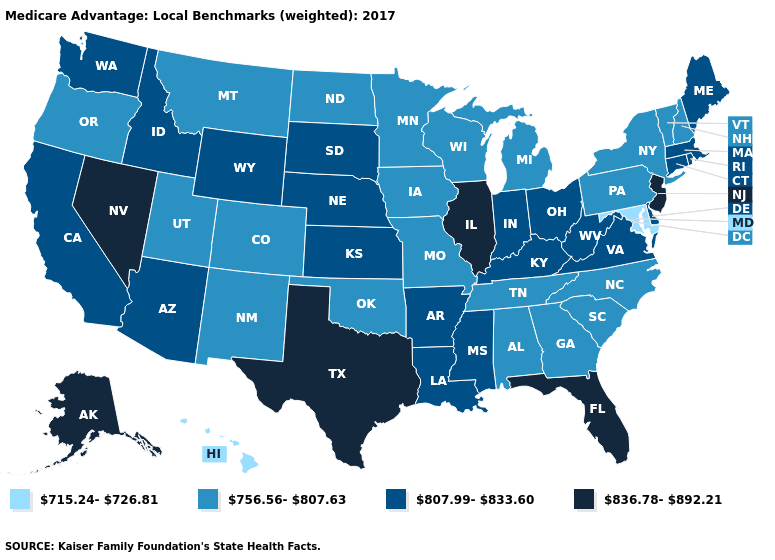What is the lowest value in the MidWest?
Be succinct. 756.56-807.63. Does Arkansas have the same value as Connecticut?
Keep it brief. Yes. What is the value of Oregon?
Answer briefly. 756.56-807.63. Name the states that have a value in the range 756.56-807.63?
Short answer required. Alabama, Colorado, Georgia, Iowa, Michigan, Minnesota, Missouri, Montana, North Carolina, North Dakota, New Hampshire, New Mexico, New York, Oklahoma, Oregon, Pennsylvania, South Carolina, Tennessee, Utah, Vermont, Wisconsin. What is the lowest value in states that border Missouri?
Give a very brief answer. 756.56-807.63. What is the highest value in the USA?
Give a very brief answer. 836.78-892.21. Which states have the lowest value in the USA?
Give a very brief answer. Hawaii, Maryland. What is the lowest value in the USA?
Keep it brief. 715.24-726.81. Name the states that have a value in the range 756.56-807.63?
Give a very brief answer. Alabama, Colorado, Georgia, Iowa, Michigan, Minnesota, Missouri, Montana, North Carolina, North Dakota, New Hampshire, New Mexico, New York, Oklahoma, Oregon, Pennsylvania, South Carolina, Tennessee, Utah, Vermont, Wisconsin. What is the value of Utah?
Answer briefly. 756.56-807.63. Among the states that border Vermont , does Massachusetts have the lowest value?
Concise answer only. No. Among the states that border Illinois , does Kentucky have the lowest value?
Be succinct. No. Is the legend a continuous bar?
Quick response, please. No. Among the states that border Alabama , does Florida have the lowest value?
Quick response, please. No. Does the first symbol in the legend represent the smallest category?
Concise answer only. Yes. 